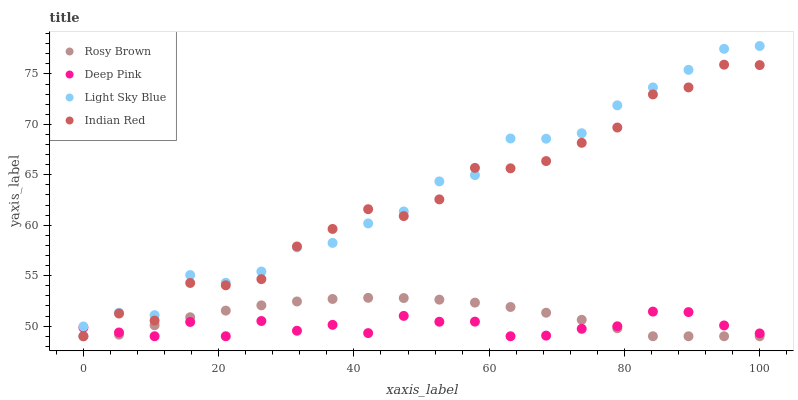Does Deep Pink have the minimum area under the curve?
Answer yes or no. Yes. Does Light Sky Blue have the maximum area under the curve?
Answer yes or no. Yes. Does Indian Red have the minimum area under the curve?
Answer yes or no. No. Does Indian Red have the maximum area under the curve?
Answer yes or no. No. Is Rosy Brown the smoothest?
Answer yes or no. Yes. Is Indian Red the roughest?
Answer yes or no. Yes. Is Deep Pink the smoothest?
Answer yes or no. No. Is Deep Pink the roughest?
Answer yes or no. No. Does Rosy Brown have the lowest value?
Answer yes or no. Yes. Does Light Sky Blue have the lowest value?
Answer yes or no. No. Does Light Sky Blue have the highest value?
Answer yes or no. Yes. Does Indian Red have the highest value?
Answer yes or no. No. Is Rosy Brown less than Light Sky Blue?
Answer yes or no. Yes. Is Light Sky Blue greater than Rosy Brown?
Answer yes or no. Yes. Does Rosy Brown intersect Indian Red?
Answer yes or no. Yes. Is Rosy Brown less than Indian Red?
Answer yes or no. No. Is Rosy Brown greater than Indian Red?
Answer yes or no. No. Does Rosy Brown intersect Light Sky Blue?
Answer yes or no. No. 